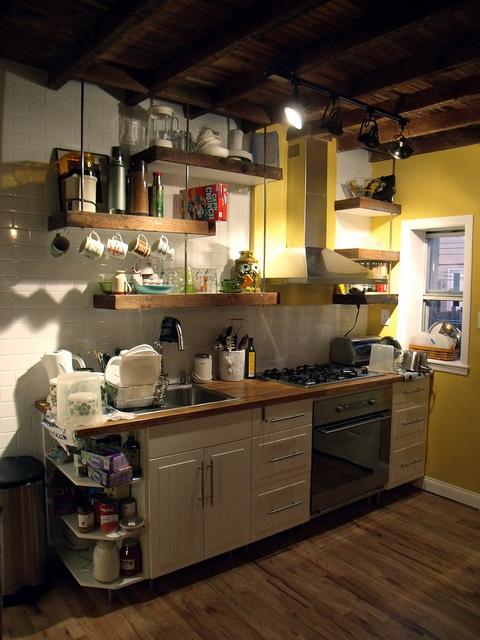Is this a restaurant kitchen?
Answer briefly. No. Is there a light on?
Concise answer only. Yes. Would this be a home kitchen?
Concise answer only. Yes. What color is the photo?
Answer briefly. Yellow. What room is this?
Answer briefly. Kitchen. Is there a box of cereal on the shelf?
Concise answer only. Yes. 